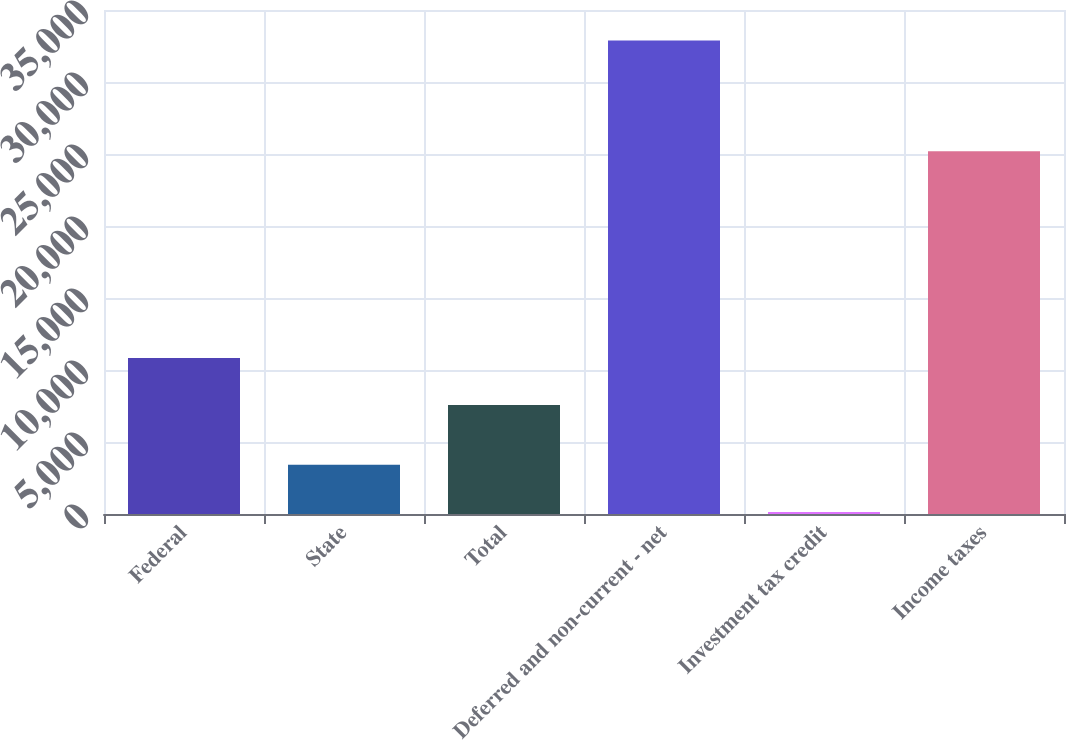Convert chart. <chart><loc_0><loc_0><loc_500><loc_500><bar_chart><fcel>Federal<fcel>State<fcel>Total<fcel>Deferred and non-current - net<fcel>Investment tax credit<fcel>Income taxes<nl><fcel>10837.2<fcel>3413.2<fcel>7562<fcel>32890<fcel>138<fcel>25190<nl></chart> 